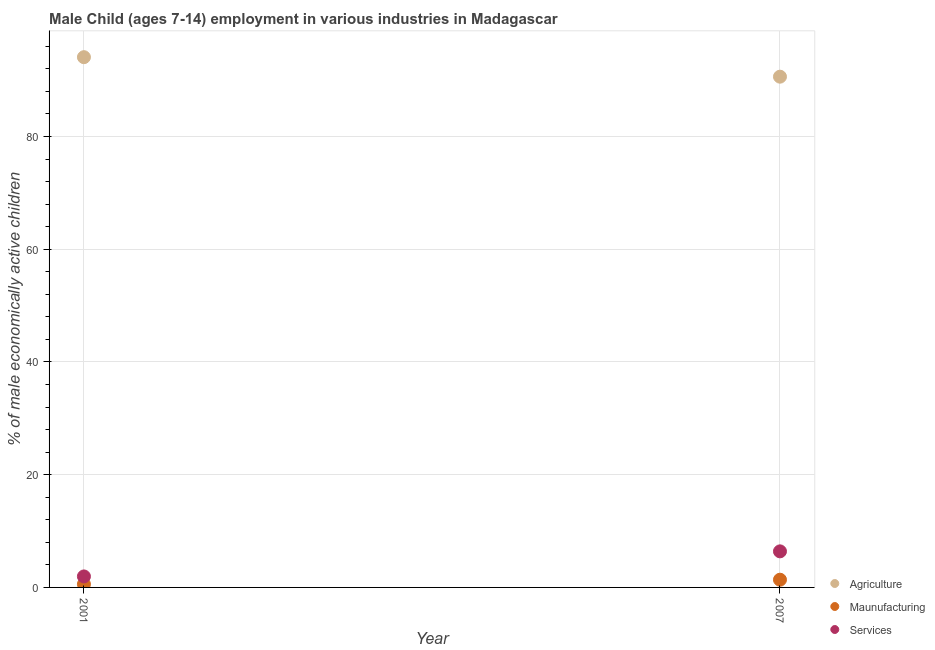How many different coloured dotlines are there?
Offer a very short reply. 3. What is the percentage of economically active children in services in 2001?
Provide a succinct answer. 1.95. Across all years, what is the minimum percentage of economically active children in manufacturing?
Keep it short and to the point. 0.57. In which year was the percentage of economically active children in services maximum?
Provide a succinct answer. 2007. What is the total percentage of economically active children in manufacturing in the graph?
Your answer should be compact. 1.94. What is the difference between the percentage of economically active children in agriculture in 2001 and that in 2007?
Offer a terse response. 3.46. What is the difference between the percentage of economically active children in services in 2007 and the percentage of economically active children in agriculture in 2001?
Keep it short and to the point. -87.68. In the year 2001, what is the difference between the percentage of economically active children in manufacturing and percentage of economically active children in agriculture?
Offer a terse response. -93.51. In how many years, is the percentage of economically active children in agriculture greater than 52 %?
Offer a very short reply. 2. What is the ratio of the percentage of economically active children in services in 2001 to that in 2007?
Provide a short and direct response. 0.3. In how many years, is the percentage of economically active children in services greater than the average percentage of economically active children in services taken over all years?
Give a very brief answer. 1. Is it the case that in every year, the sum of the percentage of economically active children in agriculture and percentage of economically active children in manufacturing is greater than the percentage of economically active children in services?
Make the answer very short. Yes. Is the percentage of economically active children in manufacturing strictly greater than the percentage of economically active children in services over the years?
Give a very brief answer. No. How many dotlines are there?
Your answer should be compact. 3. How many years are there in the graph?
Your answer should be very brief. 2. What is the difference between two consecutive major ticks on the Y-axis?
Your response must be concise. 20. Are the values on the major ticks of Y-axis written in scientific E-notation?
Ensure brevity in your answer.  No. How many legend labels are there?
Keep it short and to the point. 3. What is the title of the graph?
Keep it short and to the point. Male Child (ages 7-14) employment in various industries in Madagascar. Does "Primary" appear as one of the legend labels in the graph?
Provide a succinct answer. No. What is the label or title of the X-axis?
Your response must be concise. Year. What is the label or title of the Y-axis?
Offer a terse response. % of male economically active children. What is the % of male economically active children in Agriculture in 2001?
Give a very brief answer. 94.08. What is the % of male economically active children in Maunufacturing in 2001?
Provide a succinct answer. 0.57. What is the % of male economically active children of Services in 2001?
Ensure brevity in your answer.  1.95. What is the % of male economically active children of Agriculture in 2007?
Offer a very short reply. 90.62. What is the % of male economically active children of Maunufacturing in 2007?
Offer a very short reply. 1.37. Across all years, what is the maximum % of male economically active children of Agriculture?
Offer a terse response. 94.08. Across all years, what is the maximum % of male economically active children of Maunufacturing?
Your response must be concise. 1.37. Across all years, what is the maximum % of male economically active children in Services?
Provide a short and direct response. 6.4. Across all years, what is the minimum % of male economically active children in Agriculture?
Offer a terse response. 90.62. Across all years, what is the minimum % of male economically active children of Maunufacturing?
Keep it short and to the point. 0.57. Across all years, what is the minimum % of male economically active children in Services?
Your answer should be compact. 1.95. What is the total % of male economically active children of Agriculture in the graph?
Make the answer very short. 184.7. What is the total % of male economically active children of Maunufacturing in the graph?
Provide a succinct answer. 1.94. What is the total % of male economically active children of Services in the graph?
Provide a succinct answer. 8.35. What is the difference between the % of male economically active children in Agriculture in 2001 and that in 2007?
Give a very brief answer. 3.46. What is the difference between the % of male economically active children in Maunufacturing in 2001 and that in 2007?
Offer a very short reply. -0.8. What is the difference between the % of male economically active children in Services in 2001 and that in 2007?
Offer a terse response. -4.45. What is the difference between the % of male economically active children in Agriculture in 2001 and the % of male economically active children in Maunufacturing in 2007?
Ensure brevity in your answer.  92.71. What is the difference between the % of male economically active children in Agriculture in 2001 and the % of male economically active children in Services in 2007?
Offer a terse response. 87.68. What is the difference between the % of male economically active children in Maunufacturing in 2001 and the % of male economically active children in Services in 2007?
Provide a short and direct response. -5.83. What is the average % of male economically active children in Agriculture per year?
Your response must be concise. 92.35. What is the average % of male economically active children in Services per year?
Your answer should be very brief. 4.17. In the year 2001, what is the difference between the % of male economically active children in Agriculture and % of male economically active children in Maunufacturing?
Give a very brief answer. 93.51. In the year 2001, what is the difference between the % of male economically active children of Agriculture and % of male economically active children of Services?
Offer a very short reply. 92.13. In the year 2001, what is the difference between the % of male economically active children in Maunufacturing and % of male economically active children in Services?
Provide a short and direct response. -1.38. In the year 2007, what is the difference between the % of male economically active children of Agriculture and % of male economically active children of Maunufacturing?
Your answer should be very brief. 89.25. In the year 2007, what is the difference between the % of male economically active children of Agriculture and % of male economically active children of Services?
Provide a succinct answer. 84.22. In the year 2007, what is the difference between the % of male economically active children in Maunufacturing and % of male economically active children in Services?
Your answer should be very brief. -5.03. What is the ratio of the % of male economically active children of Agriculture in 2001 to that in 2007?
Provide a short and direct response. 1.04. What is the ratio of the % of male economically active children in Maunufacturing in 2001 to that in 2007?
Provide a short and direct response. 0.42. What is the ratio of the % of male economically active children of Services in 2001 to that in 2007?
Ensure brevity in your answer.  0.3. What is the difference between the highest and the second highest % of male economically active children of Agriculture?
Offer a very short reply. 3.46. What is the difference between the highest and the second highest % of male economically active children in Services?
Your answer should be compact. 4.45. What is the difference between the highest and the lowest % of male economically active children in Agriculture?
Make the answer very short. 3.46. What is the difference between the highest and the lowest % of male economically active children in Maunufacturing?
Ensure brevity in your answer.  0.8. What is the difference between the highest and the lowest % of male economically active children of Services?
Keep it short and to the point. 4.45. 